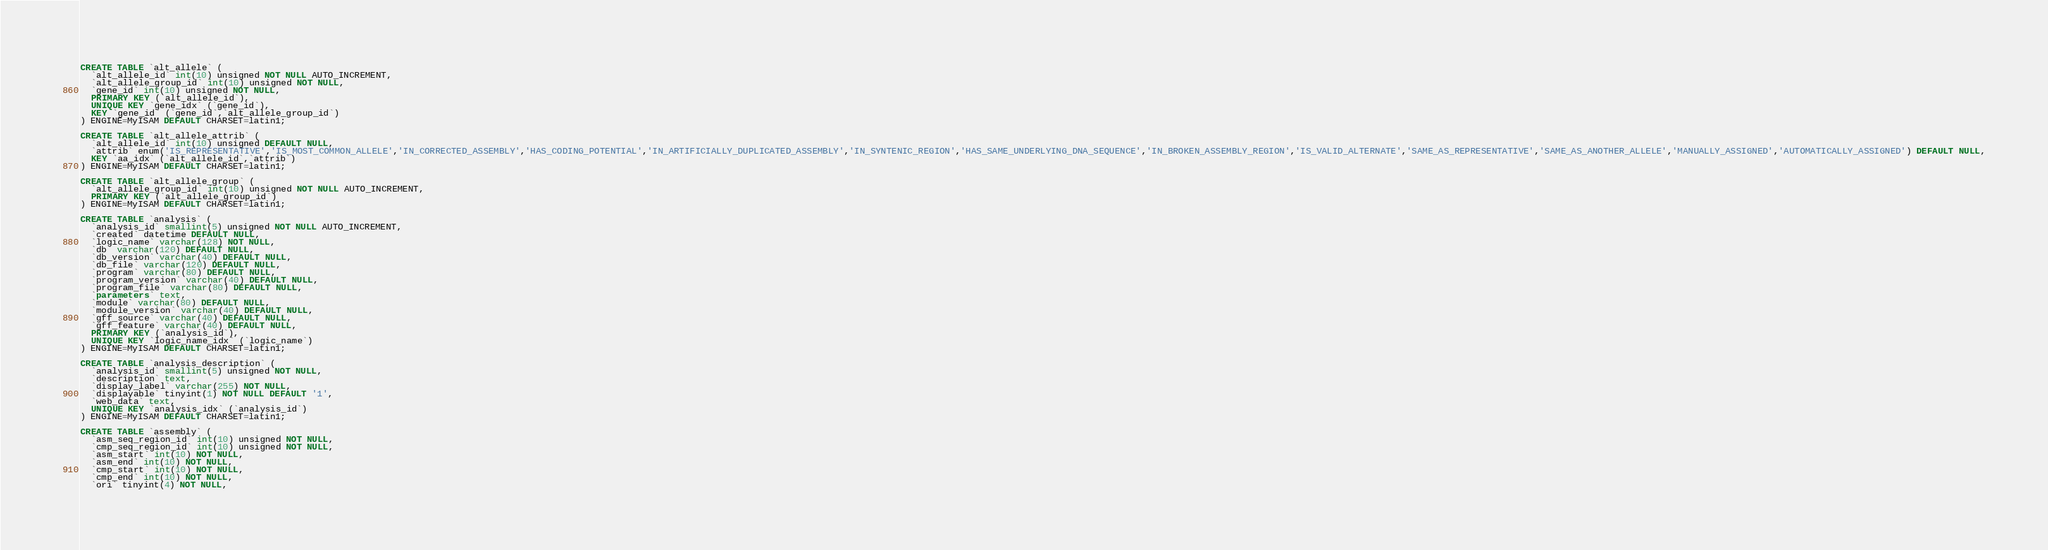Convert code to text. <code><loc_0><loc_0><loc_500><loc_500><_SQL_>CREATE TABLE `alt_allele` (
  `alt_allele_id` int(10) unsigned NOT NULL AUTO_INCREMENT,
  `alt_allele_group_id` int(10) unsigned NOT NULL,
  `gene_id` int(10) unsigned NOT NULL,
  PRIMARY KEY (`alt_allele_id`),
  UNIQUE KEY `gene_idx` (`gene_id`),
  KEY `gene_id` (`gene_id`,`alt_allele_group_id`)
) ENGINE=MyISAM DEFAULT CHARSET=latin1;

CREATE TABLE `alt_allele_attrib` (
  `alt_allele_id` int(10) unsigned DEFAULT NULL,
  `attrib` enum('IS_REPRESENTATIVE','IS_MOST_COMMON_ALLELE','IN_CORRECTED_ASSEMBLY','HAS_CODING_POTENTIAL','IN_ARTIFICIALLY_DUPLICATED_ASSEMBLY','IN_SYNTENIC_REGION','HAS_SAME_UNDERLYING_DNA_SEQUENCE','IN_BROKEN_ASSEMBLY_REGION','IS_VALID_ALTERNATE','SAME_AS_REPRESENTATIVE','SAME_AS_ANOTHER_ALLELE','MANUALLY_ASSIGNED','AUTOMATICALLY_ASSIGNED') DEFAULT NULL,
  KEY `aa_idx` (`alt_allele_id`,`attrib`)
) ENGINE=MyISAM DEFAULT CHARSET=latin1;

CREATE TABLE `alt_allele_group` (
  `alt_allele_group_id` int(10) unsigned NOT NULL AUTO_INCREMENT,
  PRIMARY KEY (`alt_allele_group_id`)
) ENGINE=MyISAM DEFAULT CHARSET=latin1;

CREATE TABLE `analysis` (
  `analysis_id` smallint(5) unsigned NOT NULL AUTO_INCREMENT,
  `created` datetime DEFAULT NULL,
  `logic_name` varchar(128) NOT NULL,
  `db` varchar(120) DEFAULT NULL,
  `db_version` varchar(40) DEFAULT NULL,
  `db_file` varchar(120) DEFAULT NULL,
  `program` varchar(80) DEFAULT NULL,
  `program_version` varchar(40) DEFAULT NULL,
  `program_file` varchar(80) DEFAULT NULL,
  `parameters` text,
  `module` varchar(80) DEFAULT NULL,
  `module_version` varchar(40) DEFAULT NULL,
  `gff_source` varchar(40) DEFAULT NULL,
  `gff_feature` varchar(40) DEFAULT NULL,
  PRIMARY KEY (`analysis_id`),
  UNIQUE KEY `logic_name_idx` (`logic_name`)
) ENGINE=MyISAM DEFAULT CHARSET=latin1;

CREATE TABLE `analysis_description` (
  `analysis_id` smallint(5) unsigned NOT NULL,
  `description` text,
  `display_label` varchar(255) NOT NULL,
  `displayable` tinyint(1) NOT NULL DEFAULT '1',
  `web_data` text,
  UNIQUE KEY `analysis_idx` (`analysis_id`)
) ENGINE=MyISAM DEFAULT CHARSET=latin1;

CREATE TABLE `assembly` (
  `asm_seq_region_id` int(10) unsigned NOT NULL,
  `cmp_seq_region_id` int(10) unsigned NOT NULL,
  `asm_start` int(10) NOT NULL,
  `asm_end` int(10) NOT NULL,
  `cmp_start` int(10) NOT NULL,
  `cmp_end` int(10) NOT NULL,
  `ori` tinyint(4) NOT NULL,</code> 